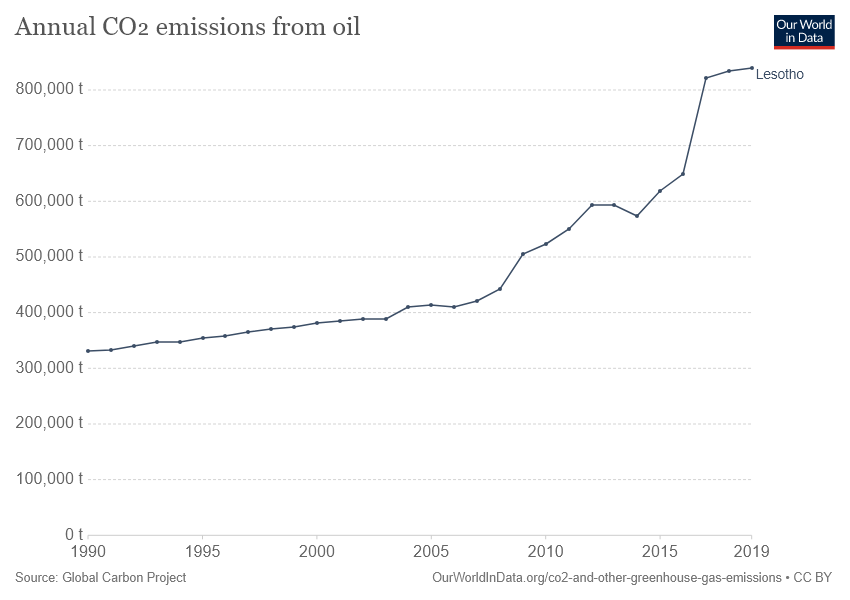Identify some key points in this picture. In the year 2019, the amount of annual CO2 emissions from oil in Lesotho was the highest on record. Lesotho is depicted in the given line graph. 